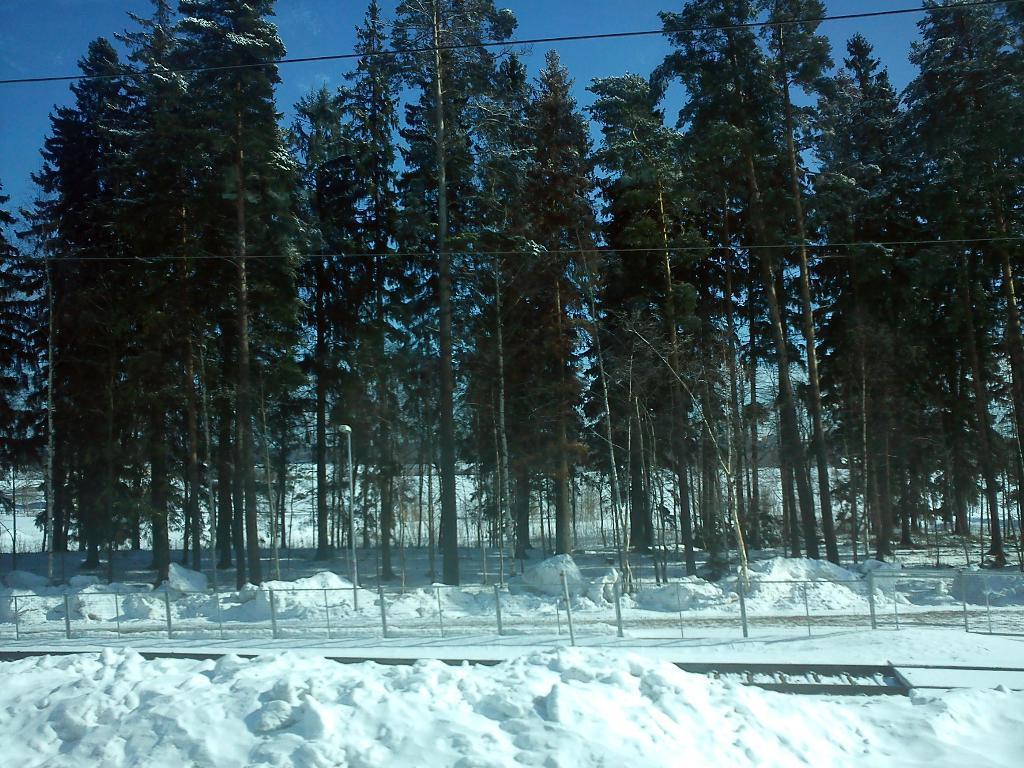Describe this image in one or two sentences. In this image we can see some trees, wires and poles, also we can see the snow and a metal object, in the background, we can see the sky. 